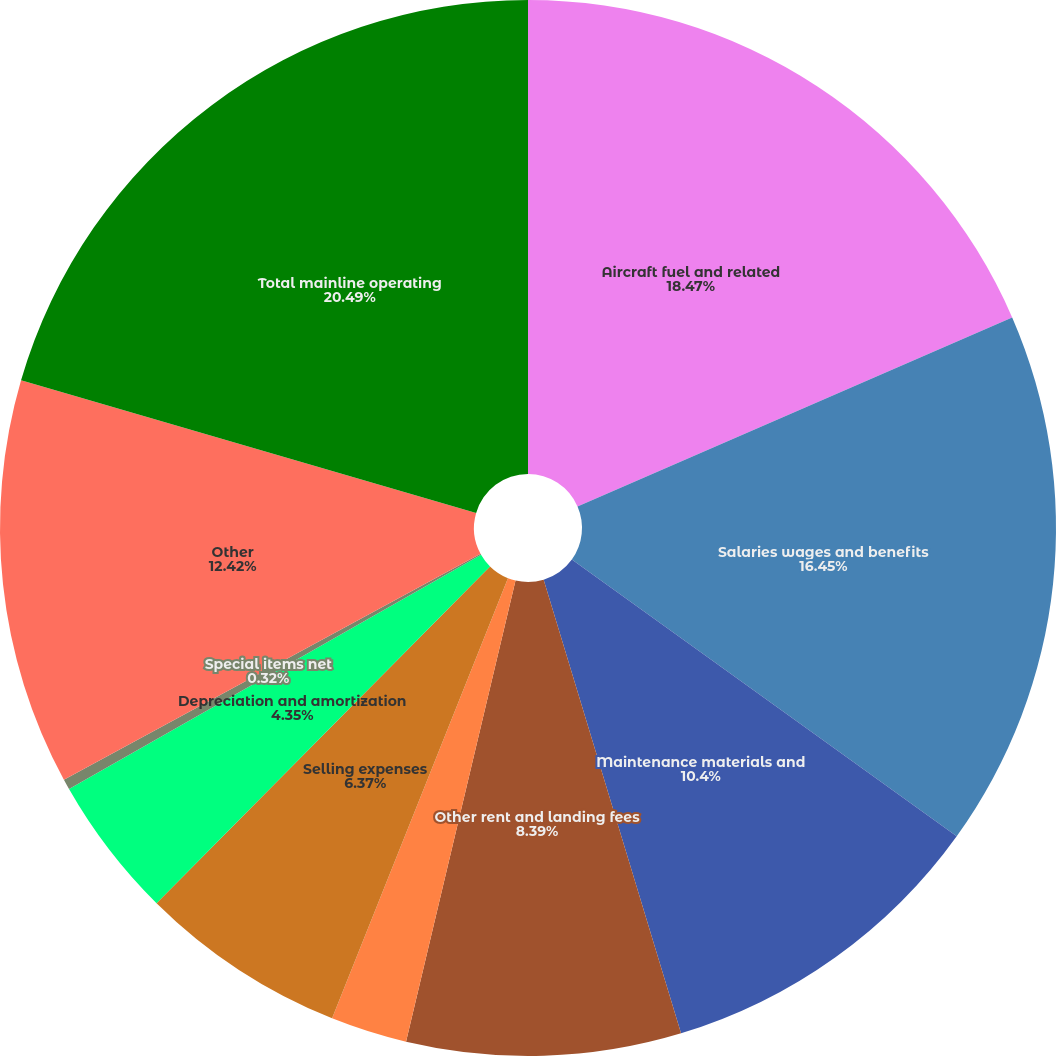<chart> <loc_0><loc_0><loc_500><loc_500><pie_chart><fcel>Aircraft fuel and related<fcel>Salaries wages and benefits<fcel>Maintenance materials and<fcel>Other rent and landing fees<fcel>Aircraft rent<fcel>Selling expenses<fcel>Depreciation and amortization<fcel>Special items net<fcel>Other<fcel>Total mainline operating<nl><fcel>18.47%<fcel>16.45%<fcel>10.4%<fcel>8.39%<fcel>2.34%<fcel>6.37%<fcel>4.35%<fcel>0.32%<fcel>12.42%<fcel>20.49%<nl></chart> 